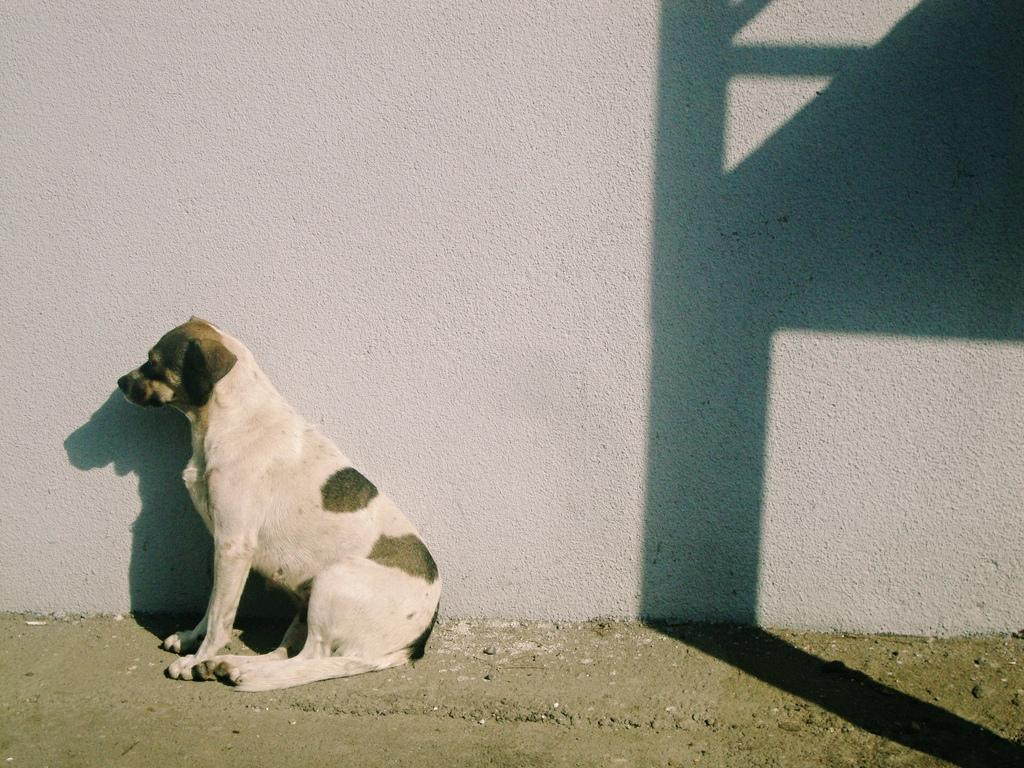What animal can be seen in the image? There is a dog in the image. What is the dog doing in the image? The dog is sitting. Can you describe any additional features in the image? There is a shadow of an object on the wall behind the dog. What type of cord is hanging from the dog's leg in the image? There is no cord hanging from the dog's leg in the image. Can you tell me how many cats are visible in the image? There are no cats present in the image; it features a dog. 